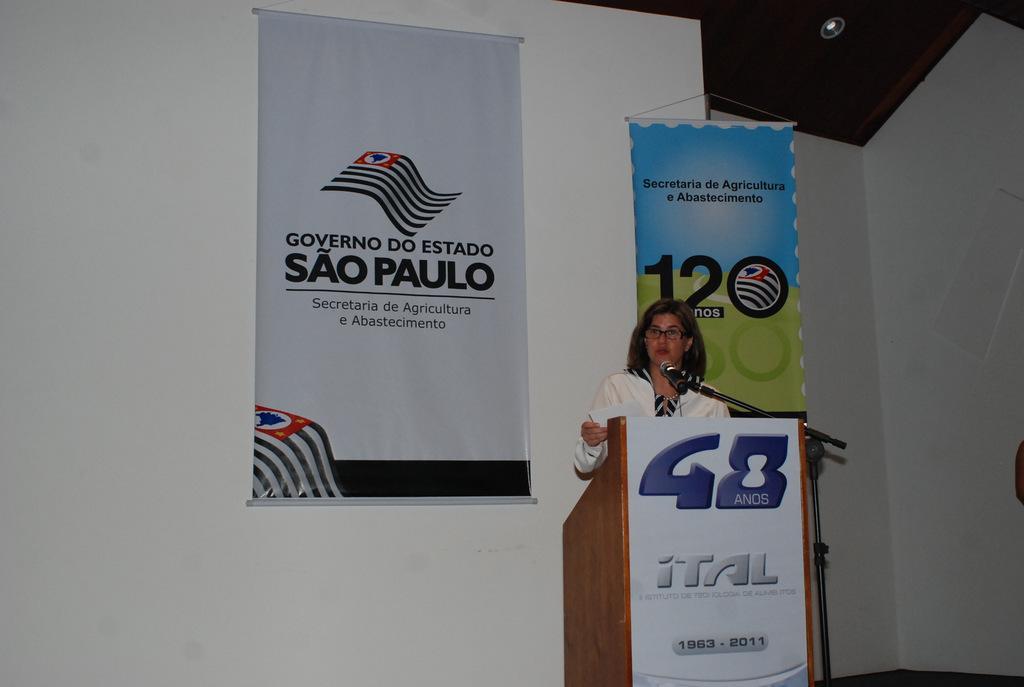Could you give a brief overview of what you see in this image? There is a woman standing and holding a paper,in front of this man we can see microphone with stand and board on podium. In the background we can see banners and wall. At the top we can see light. 